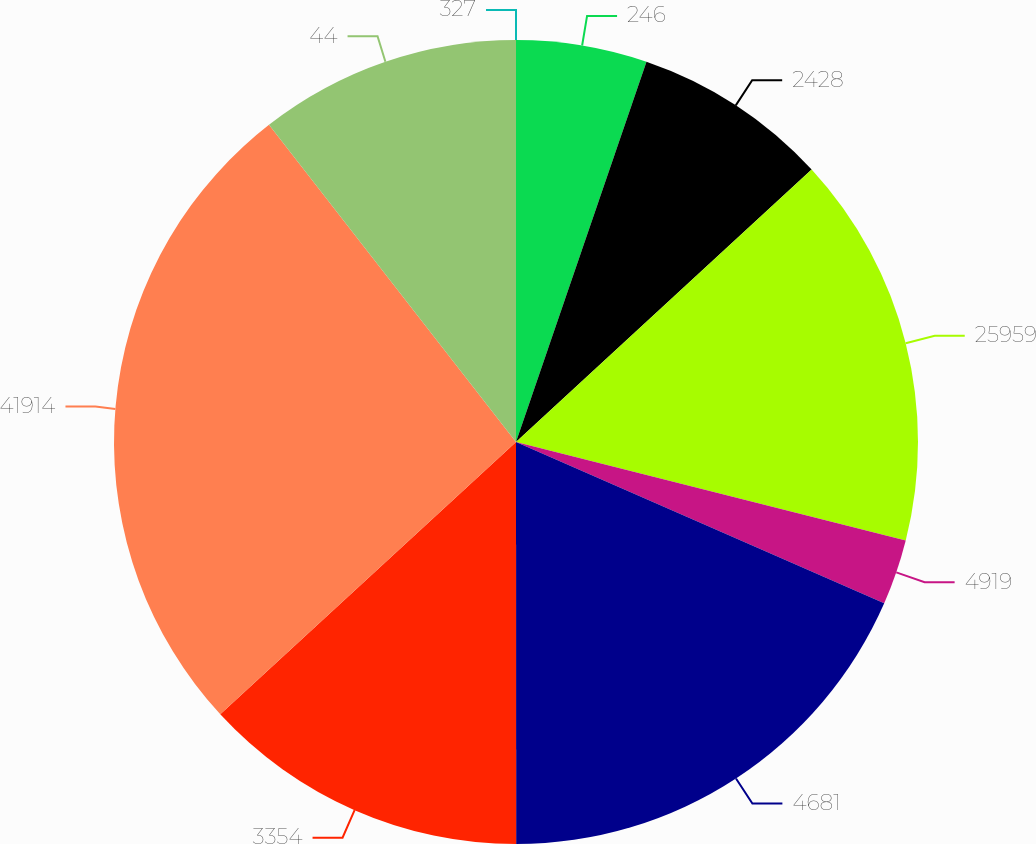Convert chart. <chart><loc_0><loc_0><loc_500><loc_500><pie_chart><fcel>327<fcel>246<fcel>2428<fcel>25959<fcel>4919<fcel>4681<fcel>3354<fcel>41914<fcel>44<nl><fcel>0.0%<fcel>5.26%<fcel>7.89%<fcel>15.79%<fcel>2.63%<fcel>18.42%<fcel>13.16%<fcel>26.31%<fcel>10.53%<nl></chart> 